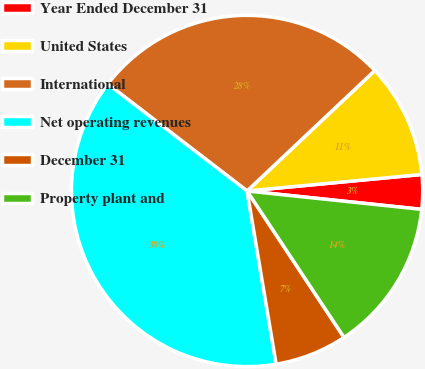Convert chart. <chart><loc_0><loc_0><loc_500><loc_500><pie_chart><fcel>Year Ended December 31<fcel>United States<fcel>International<fcel>Net operating revenues<fcel>December 31<fcel>Property plant and<nl><fcel>3.17%<fcel>10.53%<fcel>27.54%<fcel>38.07%<fcel>6.66%<fcel>14.02%<nl></chart> 